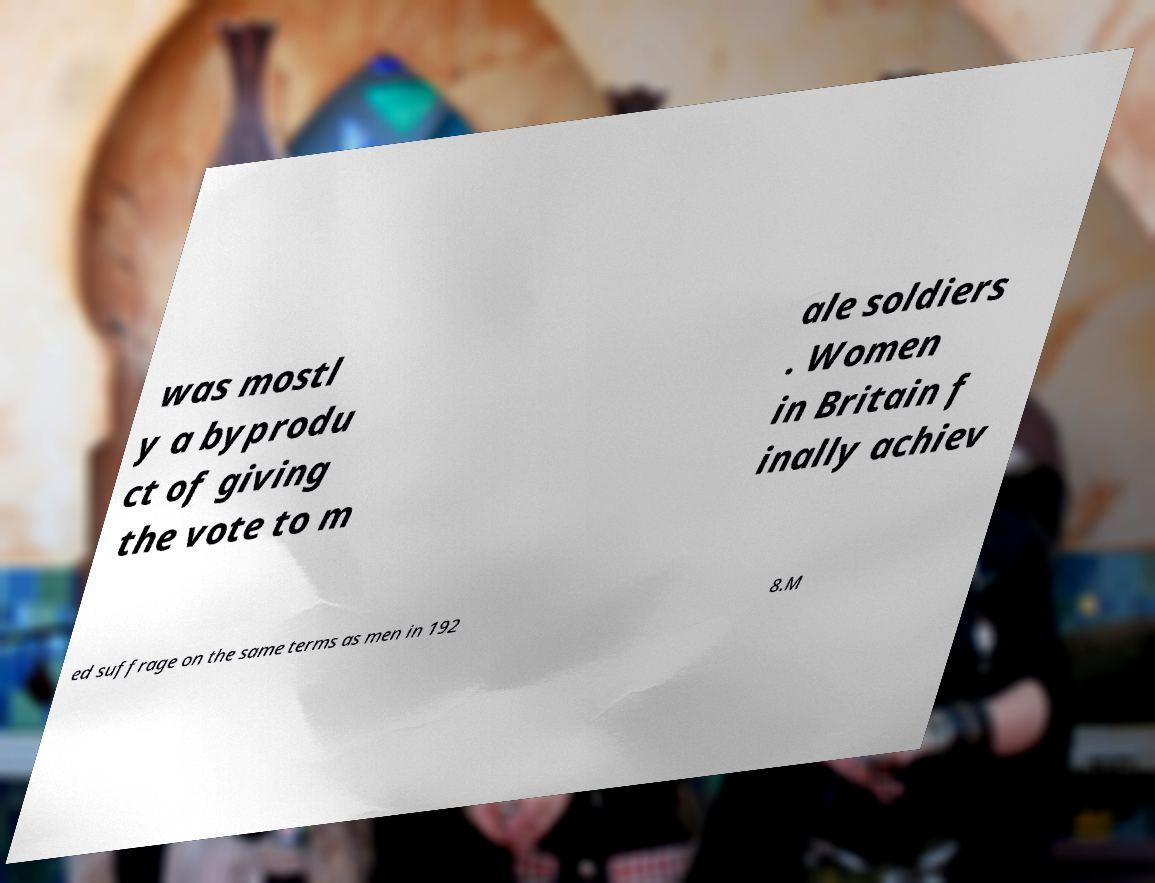Please read and relay the text visible in this image. What does it say? was mostl y a byprodu ct of giving the vote to m ale soldiers . Women in Britain f inally achiev ed suffrage on the same terms as men in 192 8.M 